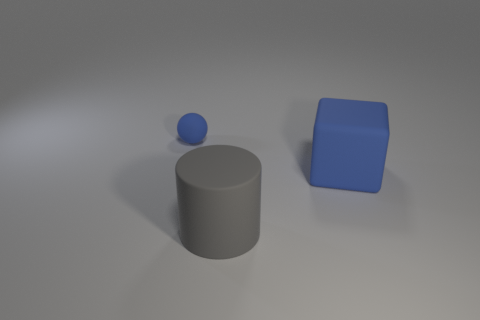What is the shape of the other large thing that is made of the same material as the large gray thing?
Keep it short and to the point. Cube. How many other things are the same shape as the tiny object?
Your answer should be compact. 0. There is a rubber ball; what number of tiny blue spheres are in front of it?
Provide a succinct answer. 0. Do the blue matte thing on the right side of the large gray cylinder and the thing that is to the left of the large gray rubber thing have the same size?
Give a very brief answer. No. What number of other objects are the same size as the gray object?
Your response must be concise. 1. There is a cube; is its size the same as the thing that is in front of the block?
Provide a succinct answer. Yes. There is a thing that is to the left of the big blue thing and behind the rubber cylinder; what is its size?
Make the answer very short. Small. Is there a tiny rubber thing of the same color as the big block?
Offer a very short reply. Yes. There is a matte thing that is in front of the blue rubber object that is in front of the tiny blue sphere; what color is it?
Offer a very short reply. Gray. Is the number of rubber things that are on the right side of the cylinder less than the number of matte objects that are to the left of the large blue rubber cube?
Offer a terse response. Yes. 